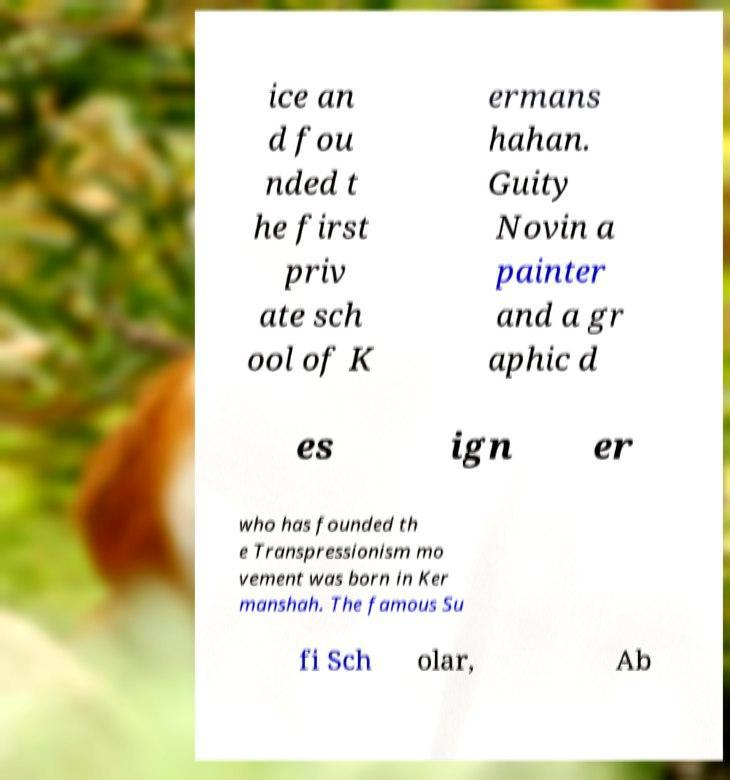Could you extract and type out the text from this image? ice an d fou nded t he first priv ate sch ool of K ermans hahan. Guity Novin a painter and a gr aphic d es ign er who has founded th e Transpressionism mo vement was born in Ker manshah. The famous Su fi Sch olar, Ab 